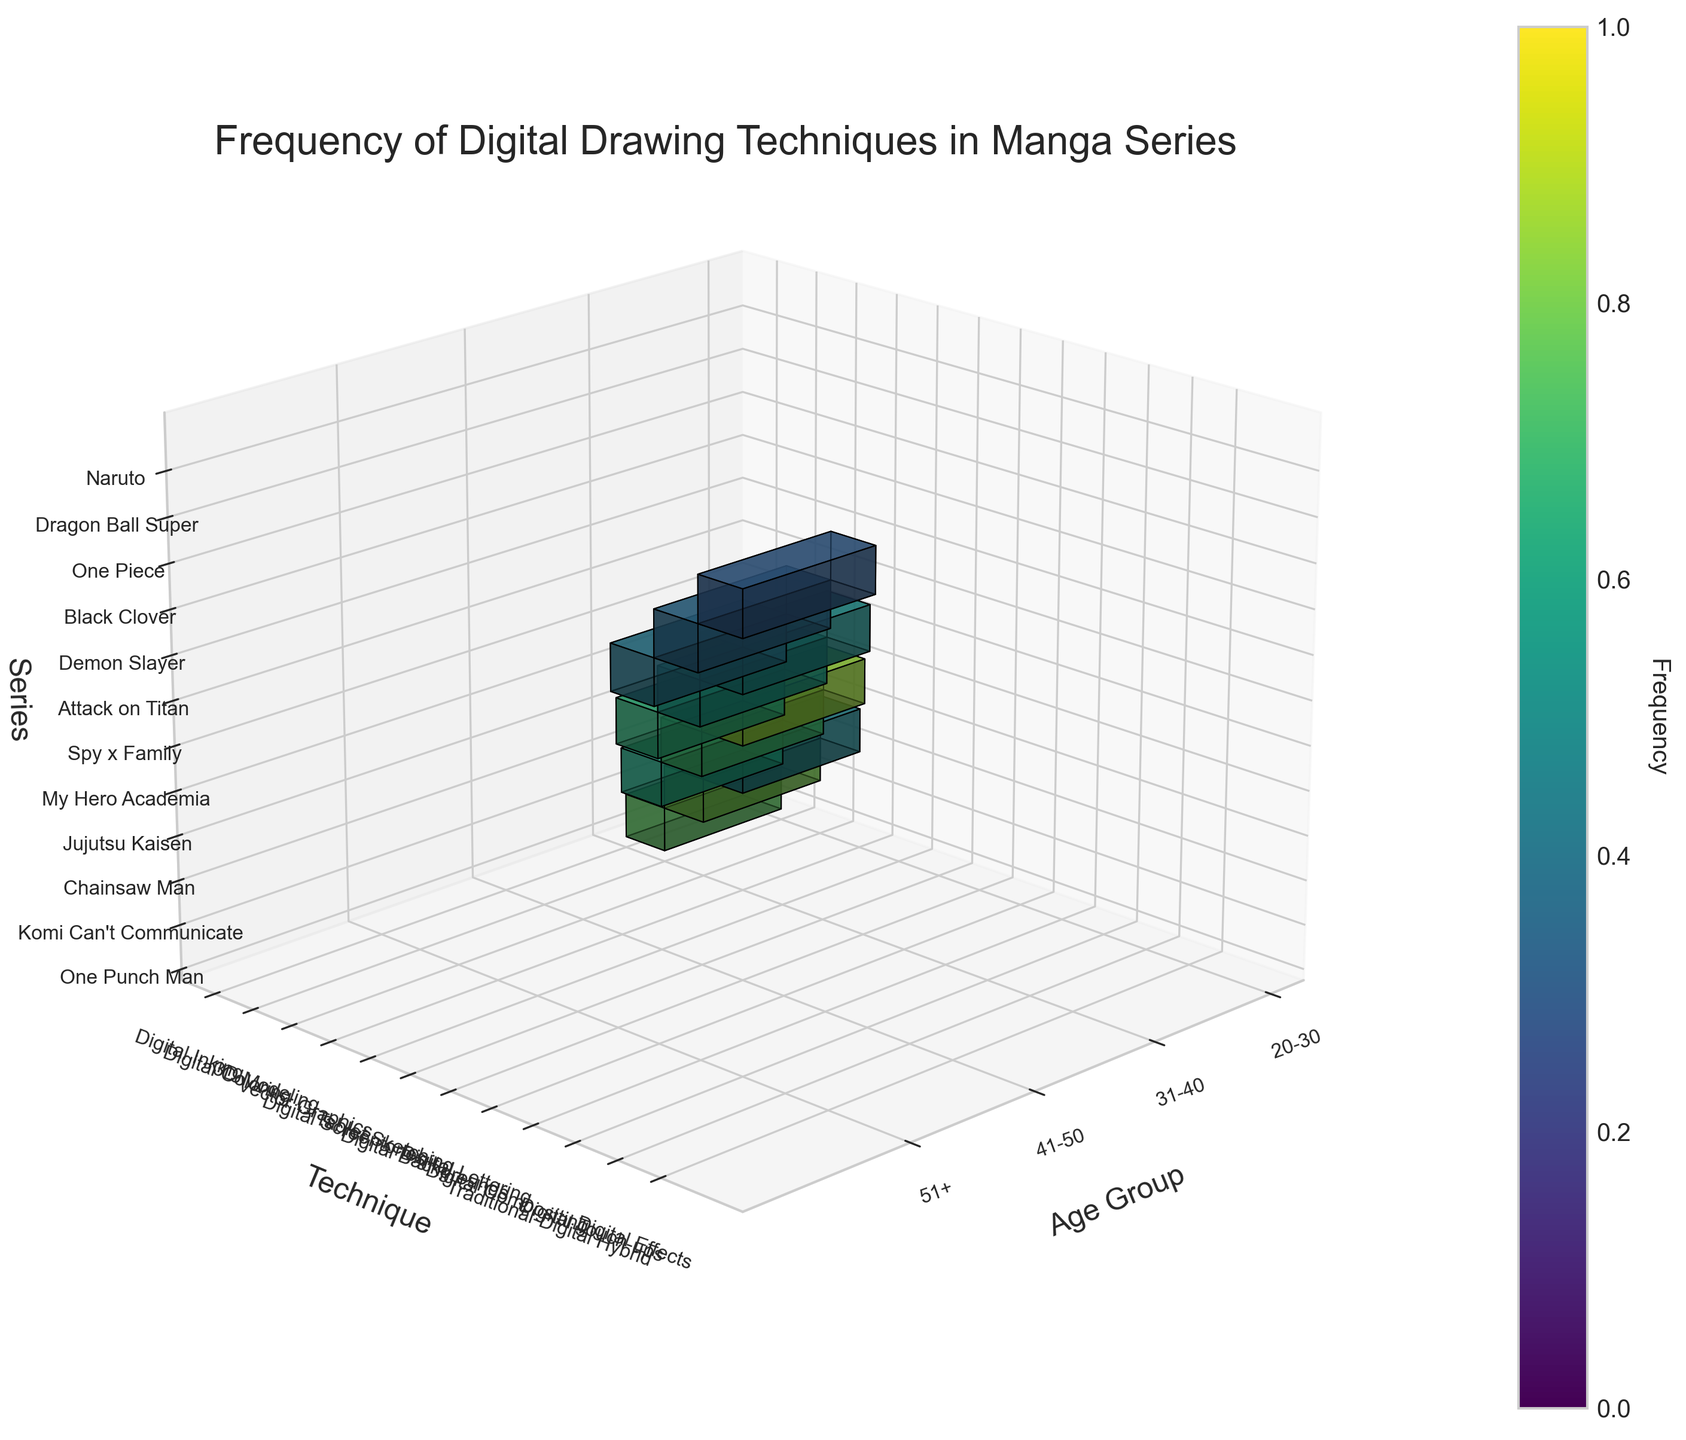What's the title of the figure? Look at the centered top text above the 3D plot. It displays the overall topic of the figure.
Answer: Frequency of Digital Drawing Techniques in Manga Series What age group has the highest frequency of using Tablet Sketching? Identify the block where Tablet Sketching is used, and check the age group label on the left. Verify the height of the bar indicating the frequency level.
Answer: 31-40 Which manga series shows digital inking being used by artists aged 20-30? Look for the Digital Inking block, then check for the coordinates corresponding to the age 20-30, and identify the series name along the z-axis.
Answer: One Punch Man Which age group uses digital effects the least frequently? Locate the Digital Effects block and compare the heights of the bars for each age group. The shortest bar corresponds to the least frequency.
Answer: 51+ Which technique has the highest usage frequency by artists aged 20-30? Check the patterns of the blocks in the age group 20-30, compare the height of different techniques' blocks and identify the highest one.
Answer: Digital Coloring In the age group 41-50, what is the combined frequency of Digital Lettering and Digital Compositing? Add the frequencies of the Digital Lettering and Digital Compositing blocks within the 41-50 age group.
Answer: 55 + 50 = 105 How does the frequency of using Digital Backgrounds compare between the 31-40 and 41-50 age groups? Identify the Digital Background blocks and compare their heights between the 31-40 and 41-50 groups.
Answer: 41-50 uses it more frequently Which technique is used least frequently across all series? Compare the heights of all technique blocks to identify the one with the consistently shortest bars across age groups and series.
Answer: Digital Effects Does the frequency of any technique show a significant drop for artists over 50 years? Compare the height of bars for techniques between the 51+ age group and younger groups to identify any notable reductions.
Answer: Yes, Digital Effects, Traditional-Digital Hybrid, and Digital Touch-ups Which series depicted in the plot uses a traditional-digital hybrid technique? Look for the Traditional-Digital Hybrid block and verify the coordinates to find the corresponding series on the z-axis.
Answer: One Piece 